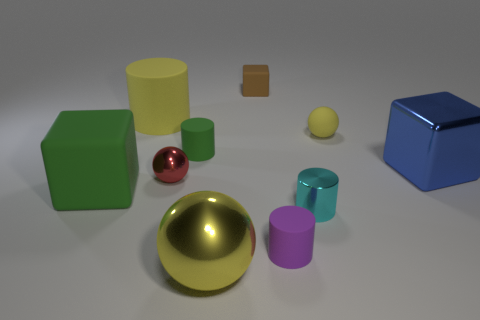Subtract all big yellow matte cylinders. How many cylinders are left? 3 Subtract 1 balls. How many balls are left? 2 Subtract all red balls. How many balls are left? 2 Subtract 0 cyan cubes. How many objects are left? 10 Subtract all cylinders. How many objects are left? 6 Subtract all red blocks. Subtract all cyan cylinders. How many blocks are left? 3 Subtract all blue spheres. How many green blocks are left? 1 Subtract all tiny blue shiny cylinders. Subtract all yellow metal balls. How many objects are left? 9 Add 8 large rubber things. How many large rubber things are left? 10 Add 5 brown objects. How many brown objects exist? 6 